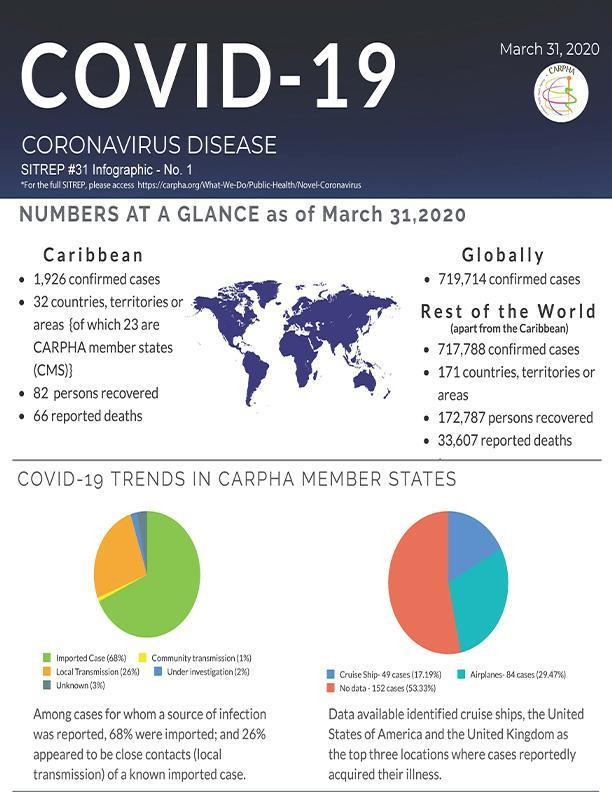In which location did cases acquire illness the most from- cruise ship or airplanes?
Answer the question with a short phrase. Airplanes Which COVID 19 trend in CARPHA member states is represented by green colour? Imported Case (68%) By what colour is community transmission represented in the pie chart- yellow, blue or green? yellow 